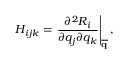<formula> <loc_0><loc_0><loc_500><loc_500>H _ { i j k } = \frac { \partial ^ { 2 } R _ { i } } { \partial q _ { j } \partial q _ { k } } \right | _ { \overline { q } } ,</formula> 